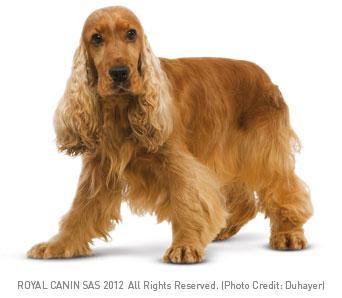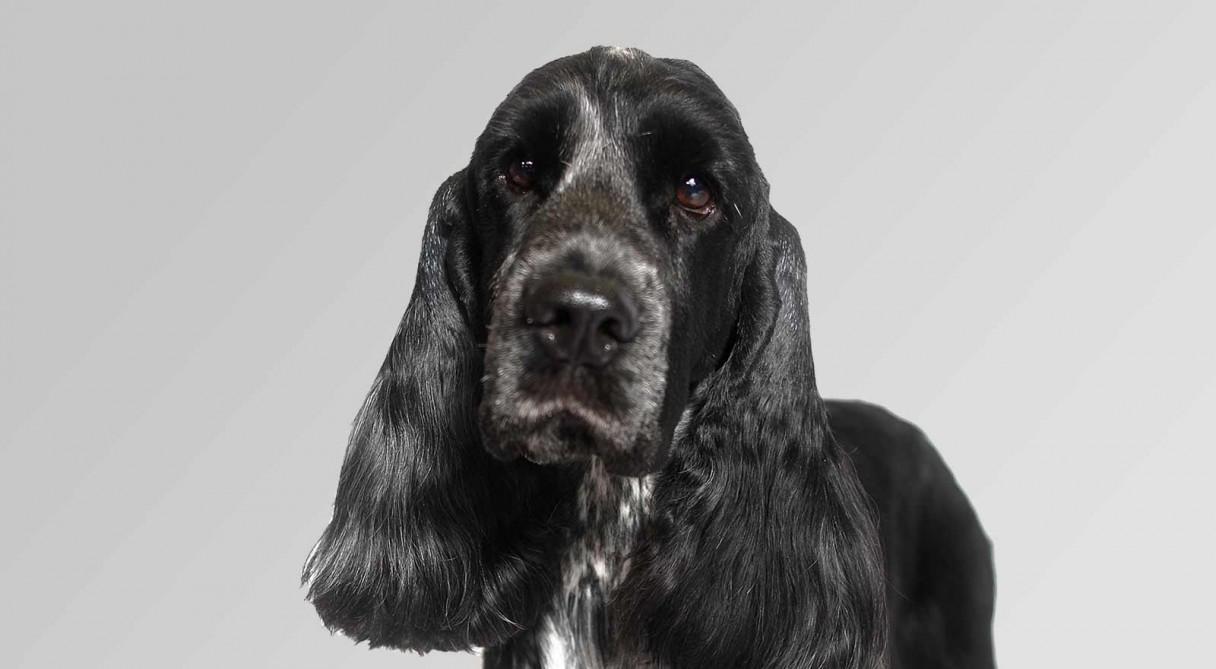The first image is the image on the left, the second image is the image on the right. Considering the images on both sides, is "Some of the dogs are shown outside." valid? Answer yes or no. No. The first image is the image on the left, the second image is the image on the right. Considering the images on both sides, is "There are multiple dogs in the right image and they are all the same color." valid? Answer yes or no. No. 